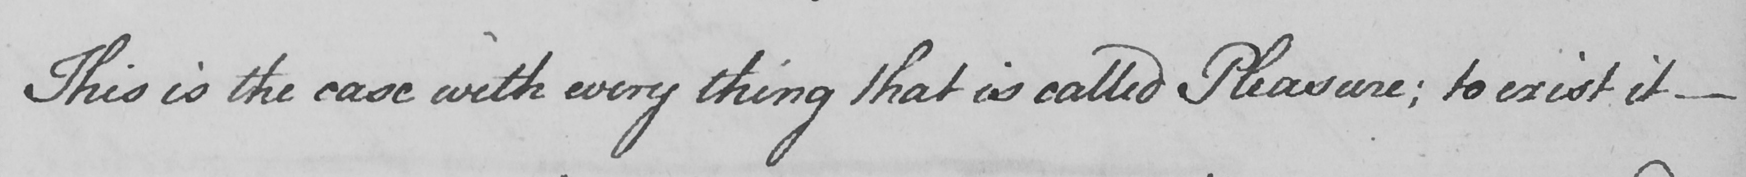Can you read and transcribe this handwriting? This is the case with every thing that is called Pleasure :  to exist it  _ 